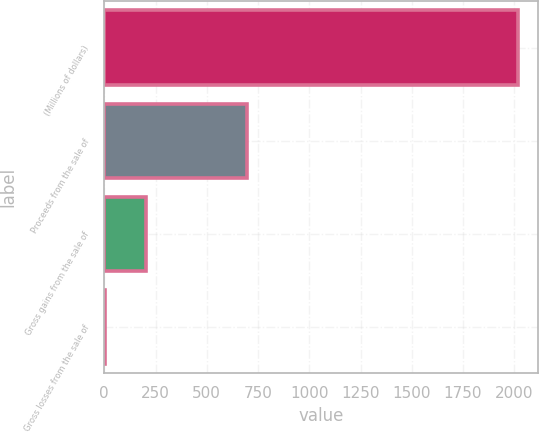Convert chart. <chart><loc_0><loc_0><loc_500><loc_500><bar_chart><fcel>(Millions of dollars)<fcel>Proceeds from the sale of<fcel>Gross gains from the sale of<fcel>Gross losses from the sale of<nl><fcel>2016<fcel>694<fcel>205.2<fcel>4<nl></chart> 